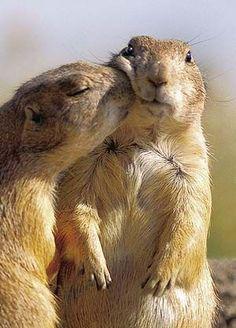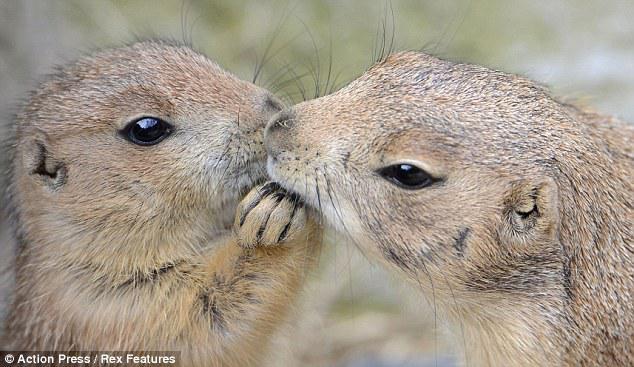The first image is the image on the left, the second image is the image on the right. For the images displayed, is the sentence "There is a total of 4 prairie dogs." factually correct? Answer yes or no. Yes. 